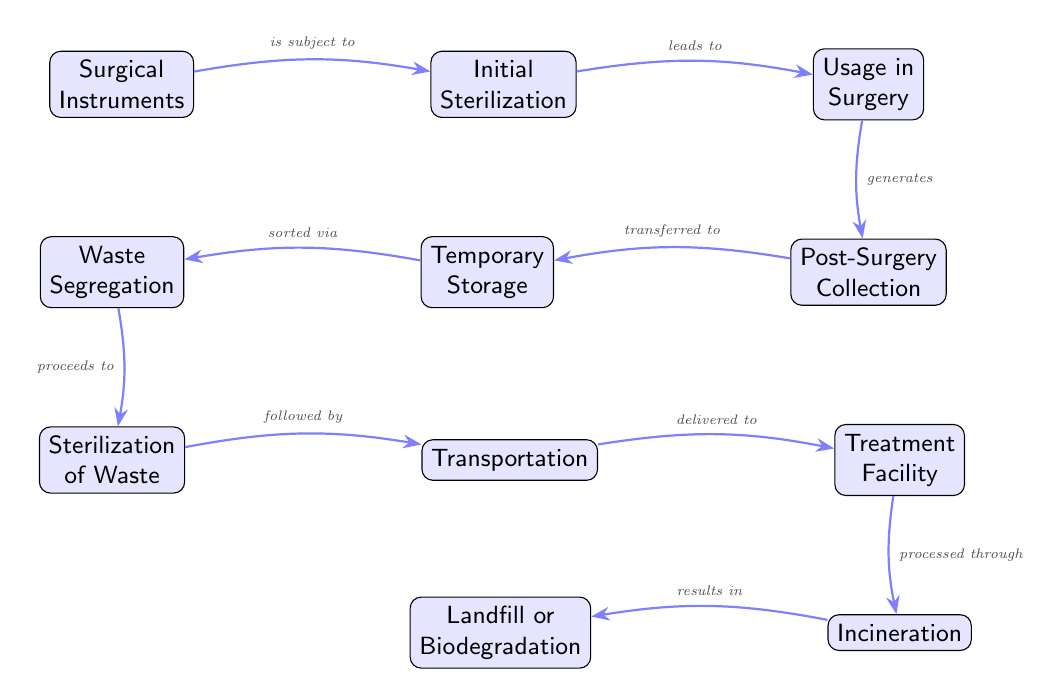What is the first step in the lifecycle of surgical waste? The diagram indicates that the lifecycle begins with "Surgical Instruments," as it is the first node on the left.
Answer: Surgical Instruments What follows "Initial Sterilization" in the process? The diagram shows an arrow leading from "Initial Sterilization" to "Usage in Surgery," indicating this as the next step.
Answer: Usage in Surgery How many major processes are depicted in the diagram? By counting the nodes, we see there are 11 major processes, including "Surgical Instruments" through to "Landfill or Biodegradation."
Answer: 11 What is the relationship between "Post-Surgery Collection" and "Temporary Storage"? The diagram shows an arrow going from "Post-Surgery Collection" to "Temporary Storage," which indicates a transfer of the collected waste to temporary storage.
Answer: transferred to What is the final state of surgical waste after treatment? The diagram shows that after "Incineration," the surgical waste ends at either "Landfill" or "Biodegradation," marking the end of the process.
Answer: Landfill or Biodegradation What process occurs after "Waste Segregation"? According to the diagram, after "Waste Segregation," the next process is "Sterilization of Waste," as indicated by the pointing arrow.
Answer: Sterilization of Waste What is the outcome of "Treatment Facility"? The arrow leading from "Treatment Facility" points towards "Incineration," indicating that the treatment is processed through this step.
Answer: Incineration What step comes right before "Transportation"? The step that comes immediately before "Transportation" in the diagram is "Sterilization of Waste," showing the required procedure prior to transport.
Answer: Sterilization of Waste What does "Incineration" result in? "Incineration" leads directly to either "Landfill" or "Biodegradation," as shown with the concluding arrow in the diagram, signifying the outcome of the incineration process.
Answer: Landfill or Biodegradation 